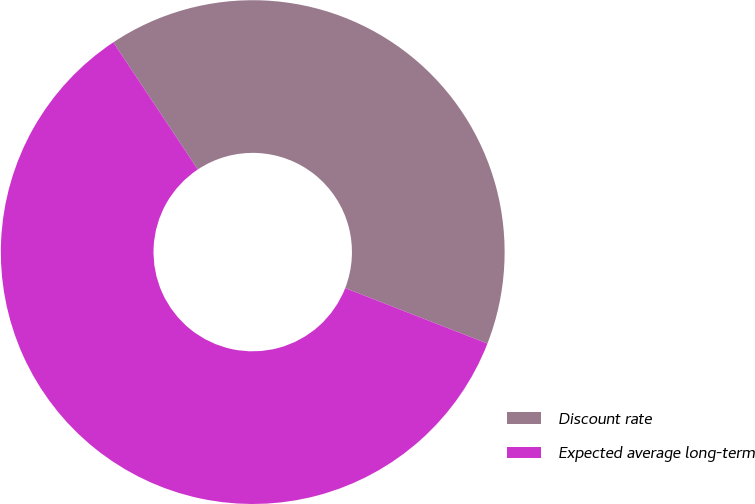Convert chart to OTSL. <chart><loc_0><loc_0><loc_500><loc_500><pie_chart><fcel>Discount rate<fcel>Expected average long-term<nl><fcel>40.25%<fcel>59.75%<nl></chart> 